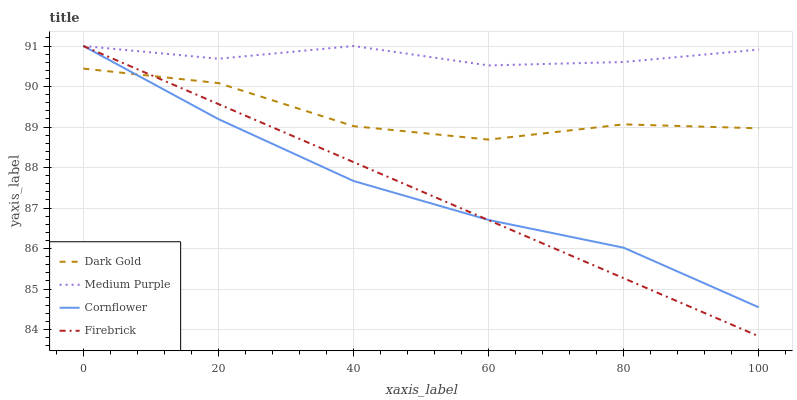Does Cornflower have the minimum area under the curve?
Answer yes or no. No. Does Cornflower have the maximum area under the curve?
Answer yes or no. No. Is Cornflower the smoothest?
Answer yes or no. No. Is Cornflower the roughest?
Answer yes or no. No. Does Cornflower have the lowest value?
Answer yes or no. No. Does Dark Gold have the highest value?
Answer yes or no. No. Is Dark Gold less than Medium Purple?
Answer yes or no. Yes. Is Medium Purple greater than Dark Gold?
Answer yes or no. Yes. Does Dark Gold intersect Medium Purple?
Answer yes or no. No. 